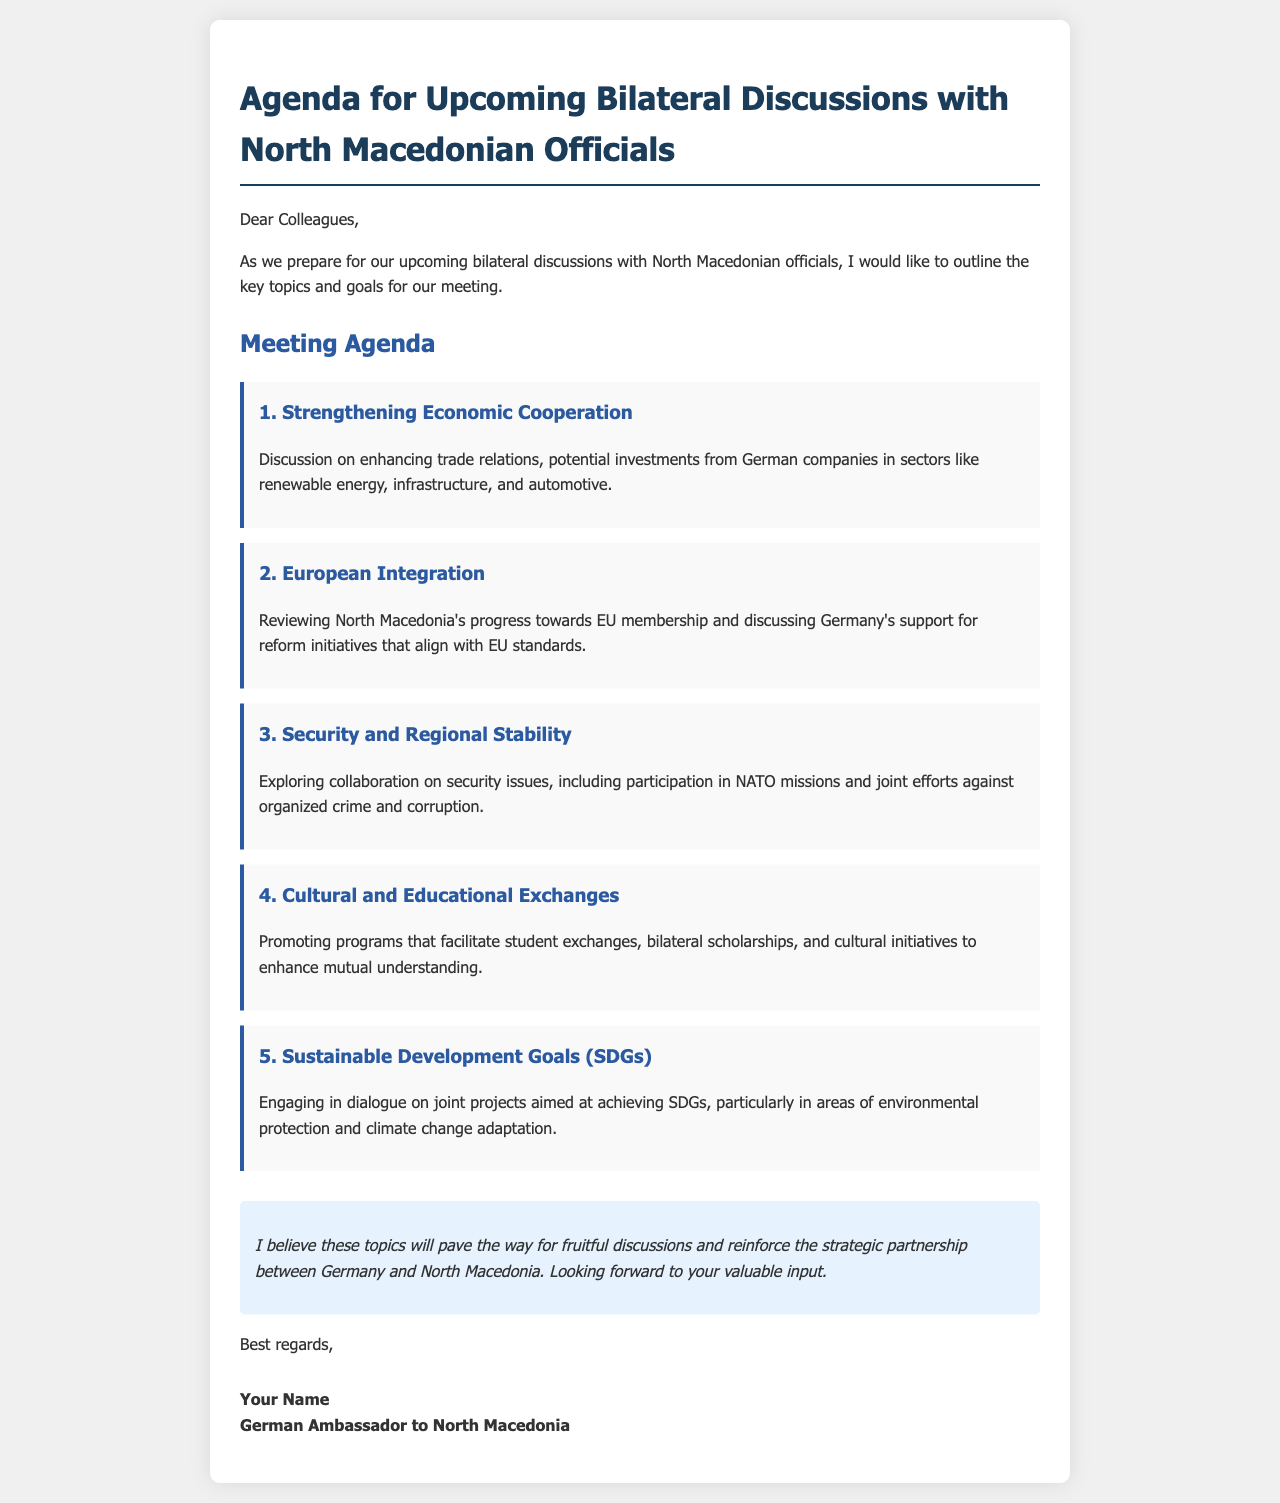what is the first agenda item? The first agenda item listed is regarding strengthening economic cooperation, which includes discussions on trade relations and investments.
Answer: Strengthening Economic Cooperation how many agenda items are listed? The document contains a list of five specific agenda items for the bilateral discussions.
Answer: 5 what is the focus of the second agenda item? The second agenda item focuses on reviewing North Macedonia's progress towards EU membership and Germany's support for reform initiatives.
Answer: European Integration which two sectors are mentioned for potential investments? The sectors mentioned for potential investments from German companies are renewable energy and infrastructure, along with automotive.
Answer: renewable energy and infrastructure what is discussed in the third agenda item? The third agenda item discusses collaboration on security issues, including NATO participation and joint efforts against organized crime and corruption.
Answer: Security and Regional Stability what kind of exchanges are promoted in the fourth agenda item? The fourth agenda item promotes cultural and educational exchanges, including student exchanges and bilateral scholarships.
Answer: Cultural and Educational Exchanges what is a key goal in the fifth agenda item? The fifth agenda item aims for engaging in dialogue on joint projects aimed at achieving Sustainable Development Goals, particularly in environmental protection.
Answer: Sustainable Development Goals (SDGs) 